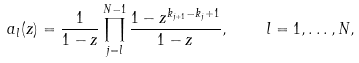Convert formula to latex. <formula><loc_0><loc_0><loc_500><loc_500>a _ { l } ( z ) = \frac { 1 } { 1 - z } \prod _ { j = l } ^ { N - 1 } \frac { 1 - z ^ { k _ { j + 1 } - k _ { j } + 1 } } { 1 - z } , \quad l = 1 , \dots , N ,</formula> 